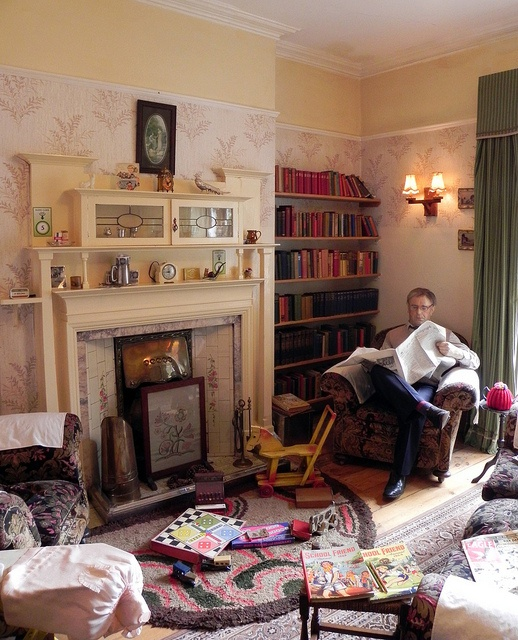Describe the objects in this image and their specific colors. I can see book in tan, black, maroon, lightgray, and brown tones, couch in tan, white, darkgray, black, and gray tones, chair in tan, black, darkgray, gray, and maroon tones, people in tan, black, lightgray, darkgray, and gray tones, and couch in tan, lightgray, and brown tones in this image. 